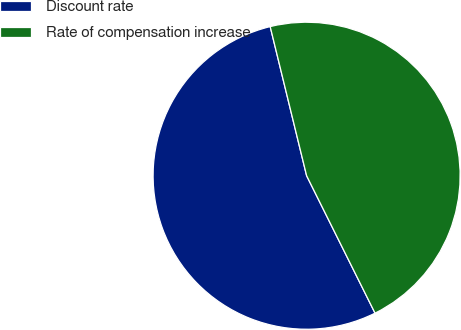Convert chart to OTSL. <chart><loc_0><loc_0><loc_500><loc_500><pie_chart><fcel>Discount rate<fcel>Rate of compensation increase<nl><fcel>53.54%<fcel>46.46%<nl></chart> 